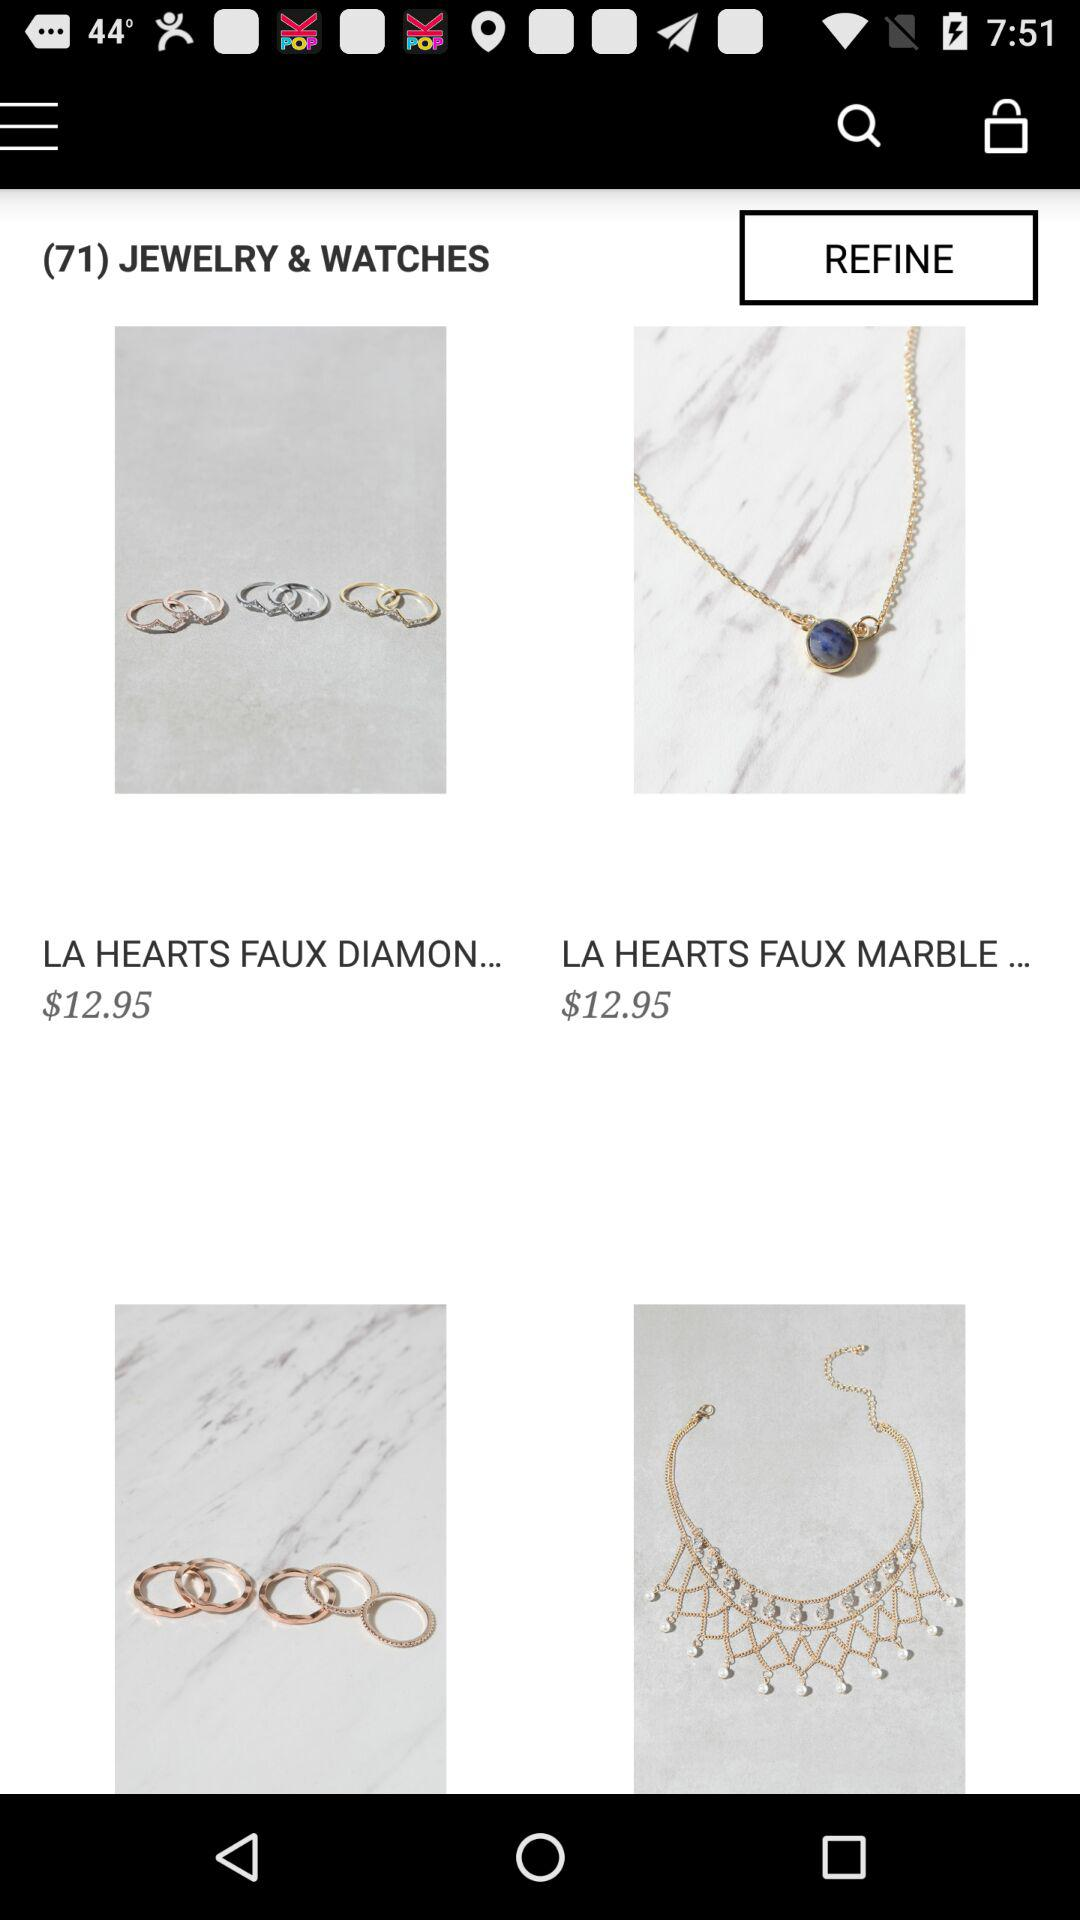What is the price of "LA HEARTS FAUX DIAMON..."? The price of "LA HEARTS FAUX DIAMON..." is $12.95. 